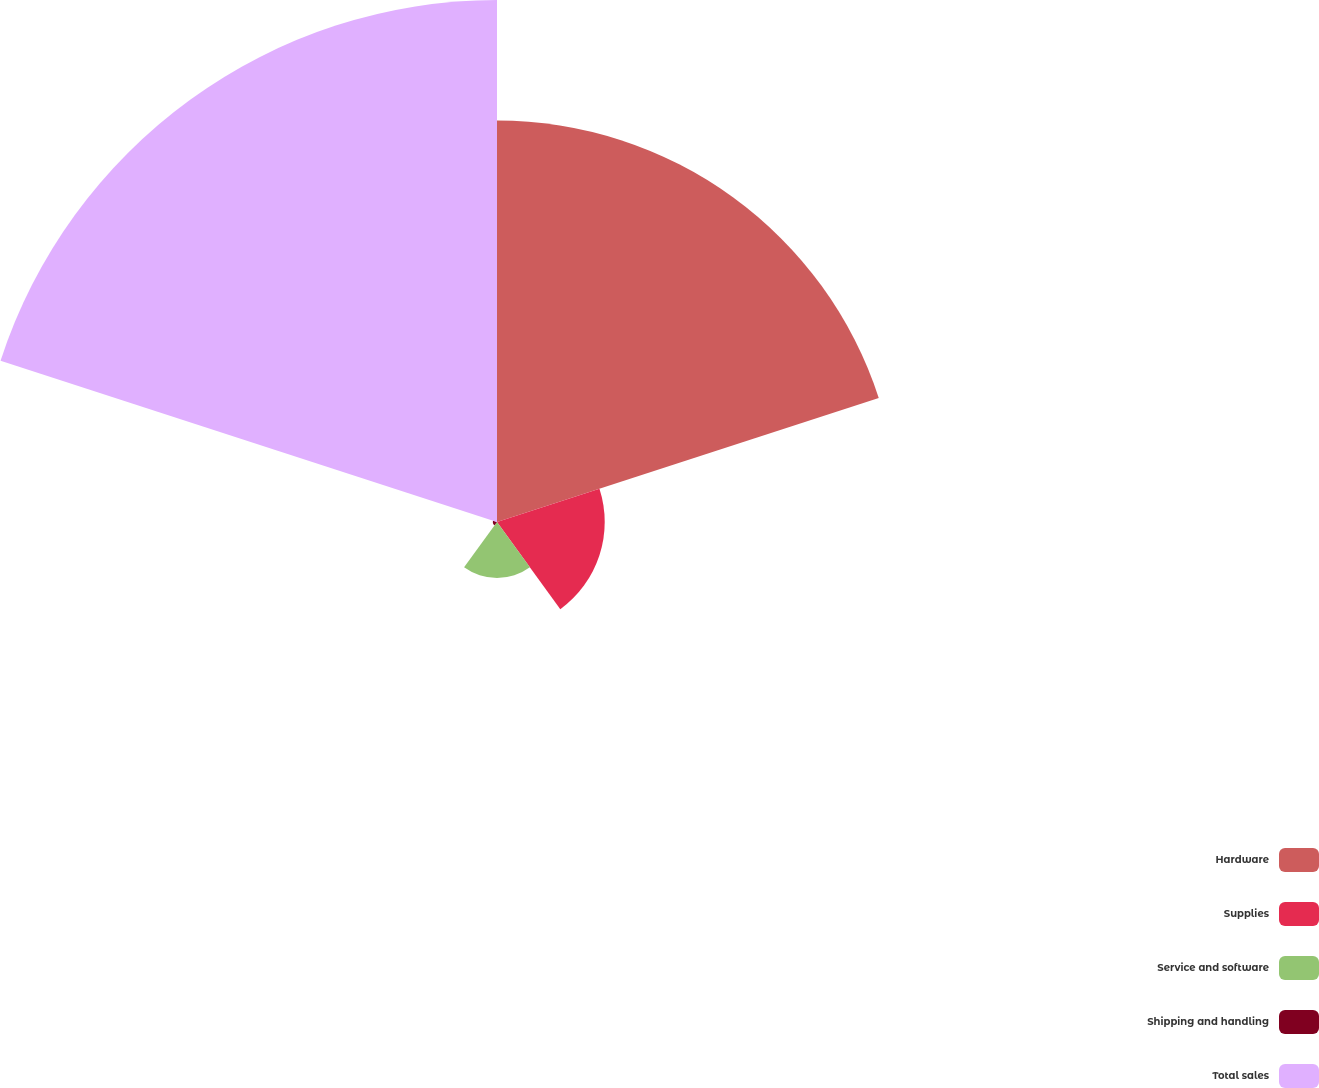<chart> <loc_0><loc_0><loc_500><loc_500><pie_chart><fcel>Hardware<fcel>Supplies<fcel>Service and software<fcel>Shipping and handling<fcel>Total sales<nl><fcel>36.78%<fcel>9.87%<fcel>5.13%<fcel>0.38%<fcel>47.83%<nl></chart> 